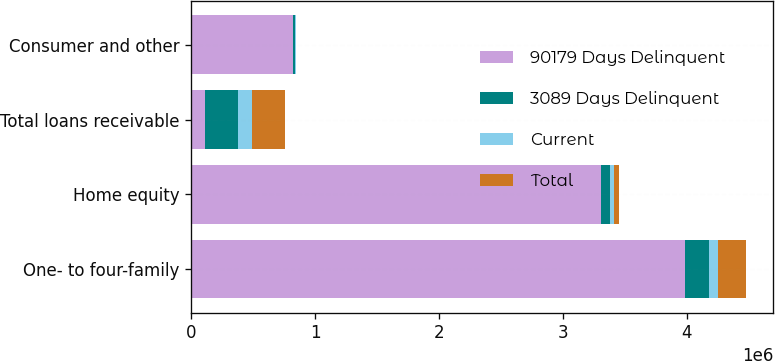Convert chart. <chart><loc_0><loc_0><loc_500><loc_500><stacked_bar_chart><ecel><fcel>One- to four-family<fcel>Home equity<fcel>Total loans receivable<fcel>Consumer and other<nl><fcel>90179 Days Delinquent<fcel>3.98805e+06<fcel>3.30915e+06<fcel>108084<fcel>819468<nl><fcel>3089 Days Delinquent<fcel>190109<fcel>69188<fcel>271577<fcel>19101<nl><fcel>Current<fcel>69522<fcel>35721<fcel>108084<fcel>6178<nl><fcel>Total<fcel>227115<fcel>39904<fcel>267019<fcel>195<nl></chart> 